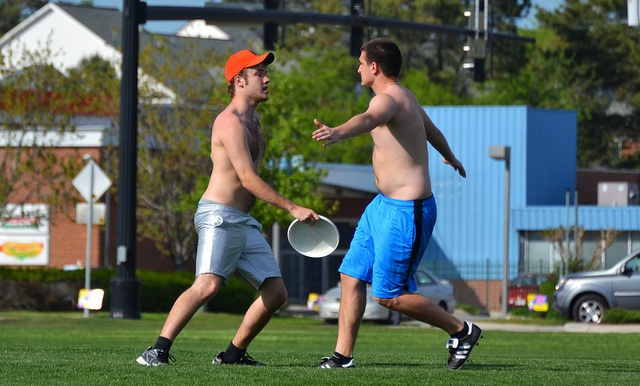Describe the objects in this image and their specific colors. I can see people in purple, black, tan, lightblue, and gray tones, people in purple, black, tan, gray, and brown tones, car in purple, black, gray, and darkgray tones, car in purple, gray, darkgray, and black tones, and frisbee in purple, gray, white, and darkgray tones in this image. 